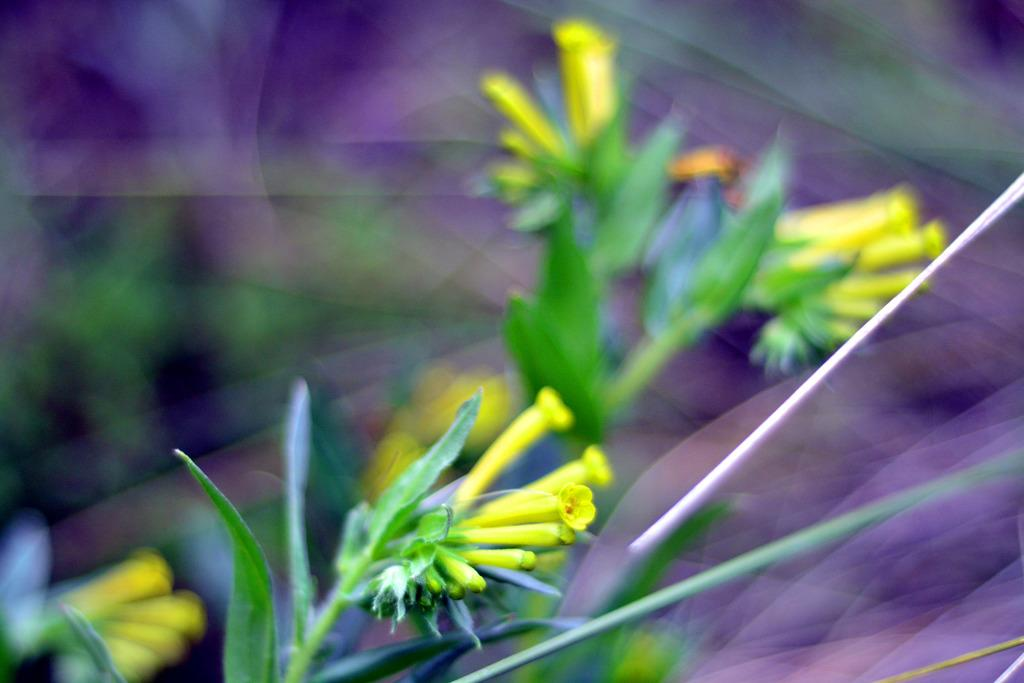What type of plant life is present in the image? There are flower buds in the image. What color are the leaves of the plants? The plants have green leaves. What color can be seen in the background of the image? There is a violet color visible in the background of the image. What type of crown is being used as bait in the image? There is no crown or bait present in the image; it features flower buds and green leaves. 